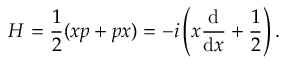<formula> <loc_0><loc_0><loc_500><loc_500>H = { \frac { 1 } { 2 } } ( x p + p x ) = - i \left ( x { \frac { d } { d x } } + { \frac { 1 } { 2 } } \right ) .</formula> 